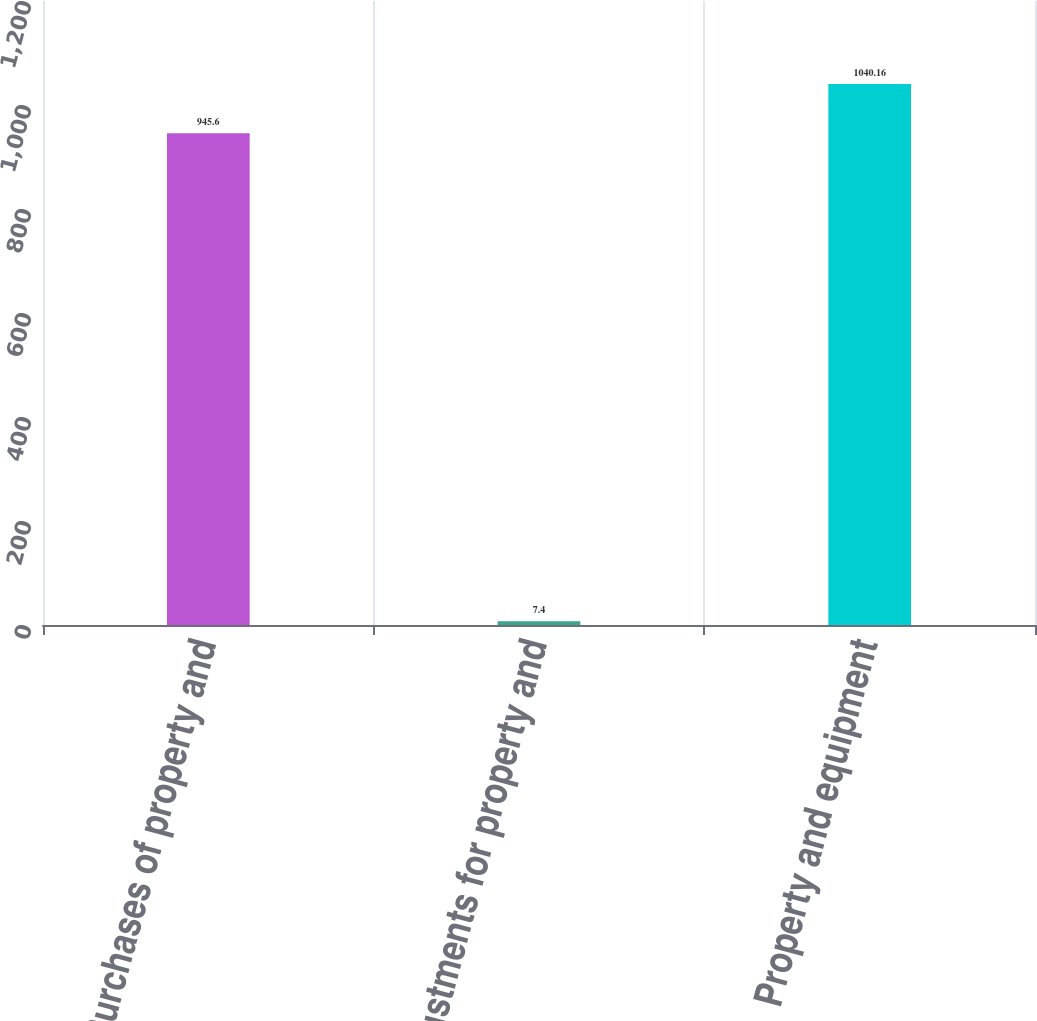Convert chart to OTSL. <chart><loc_0><loc_0><loc_500><loc_500><bar_chart><fcel>Purchases of property and<fcel>Adjustments for property and<fcel>Property and equipment<nl><fcel>945.6<fcel>7.4<fcel>1040.16<nl></chart> 